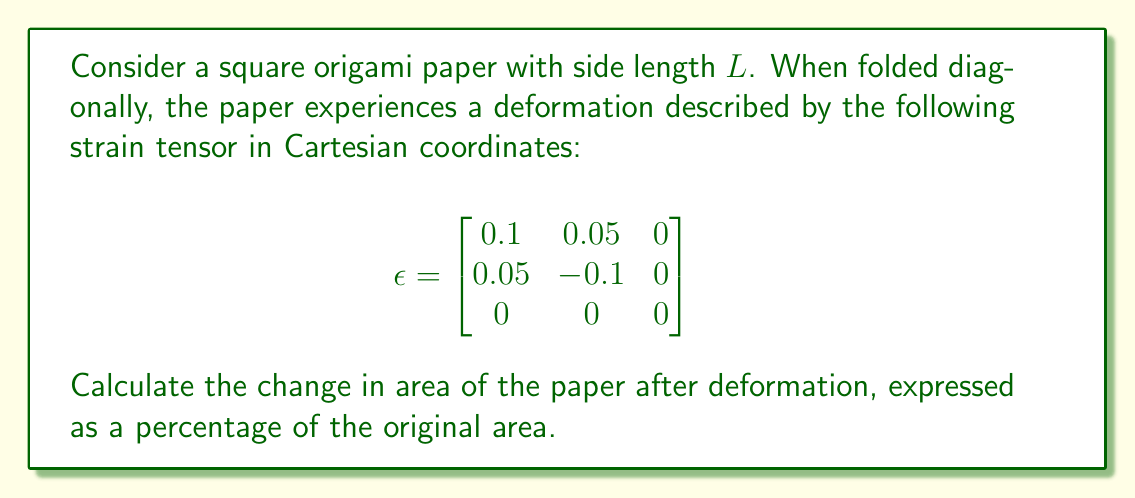Provide a solution to this math problem. Let's approach this step-by-step:

1) The change in area due to deformation is related to the trace of the strain tensor. For small deformations, the relative change in area is approximately equal to the sum of the diagonal elements of the strain tensor.

2) The trace of the strain tensor is:
   $\text{tr}(\epsilon) = \epsilon_{11} + \epsilon_{22} + \epsilon_{33}$

3) From the given strain tensor:
   $\epsilon_{11} = 0.1$
   $\epsilon_{22} = -0.1$
   $\epsilon_{33} = 0$

4) Calculate the trace:
   $\text{tr}(\epsilon) = 0.1 + (-0.1) + 0 = 0$

5) The relative change in area is:
   $\frac{\Delta A}{A} \approx \text{tr}(\epsilon) = 0$

6) To express this as a percentage, multiply by 100:
   Percentage change = $0 \times 100\% = 0\%$

Therefore, there is no change in the area of the origami paper after deformation.
Answer: 0% 